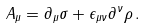Convert formula to latex. <formula><loc_0><loc_0><loc_500><loc_500>A _ { \mu } = \partial _ { \mu } \sigma + \epsilon _ { \mu \nu } \partial ^ { \nu } \rho \, .</formula> 